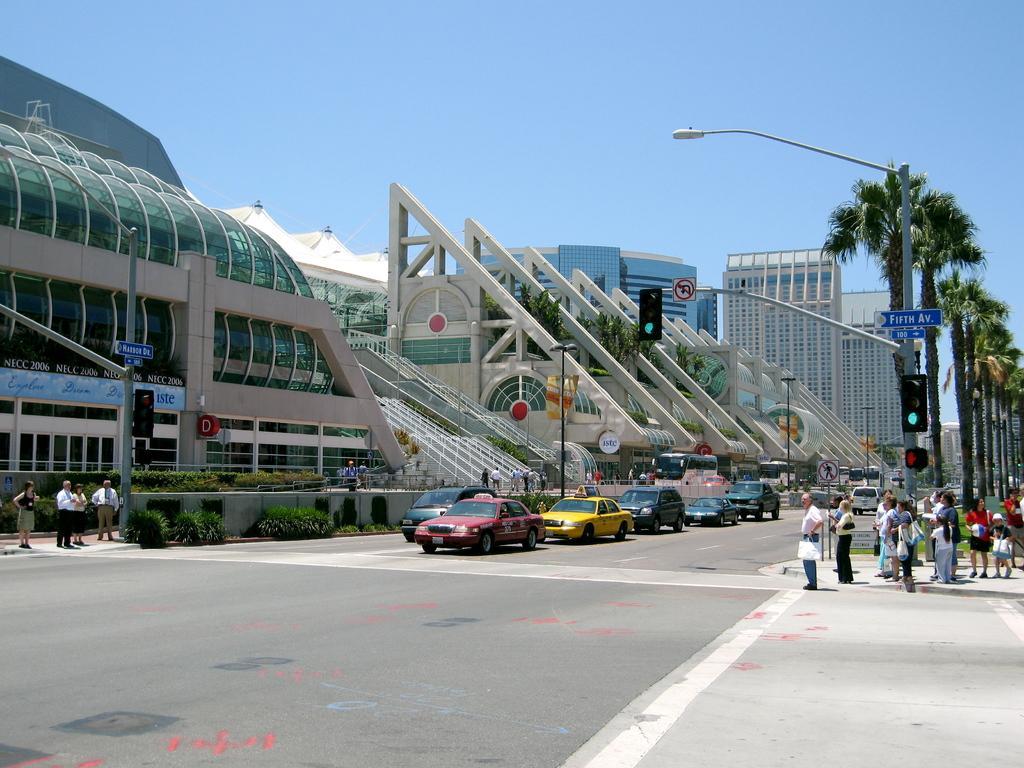Could you give a brief overview of what you see in this image? In this picture I can see few vehicles are on the roadside few people are standing, around there are some buildings and trees. 